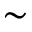<formula> <loc_0><loc_0><loc_500><loc_500>\sim</formula> 